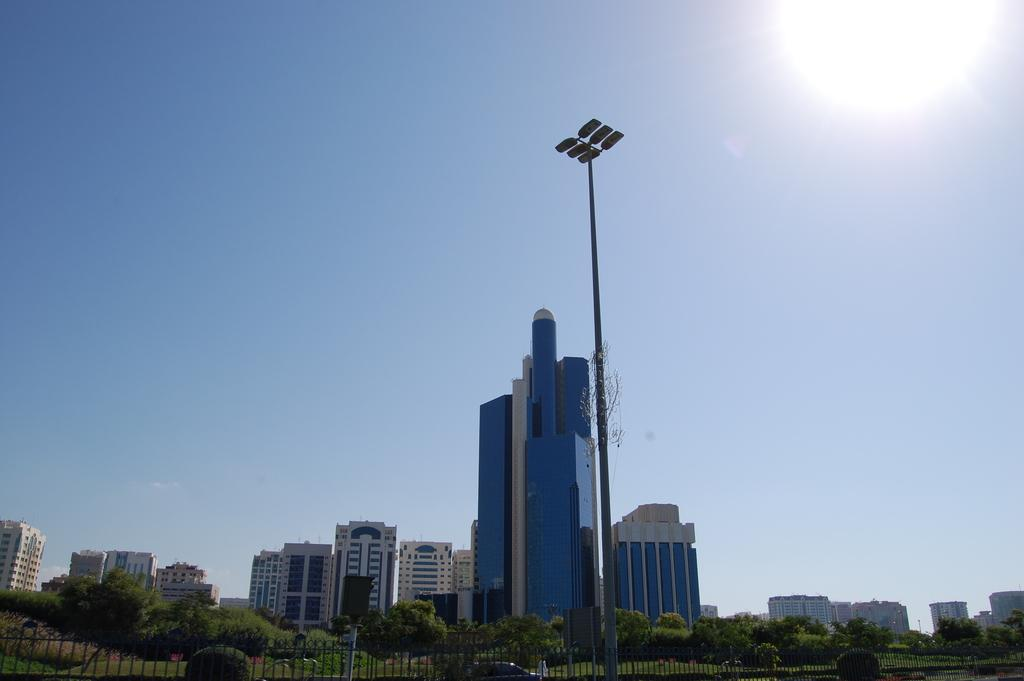What type of structures can be seen in the image? There are many buildings in the image. What natural elements are present in the image? Trees are present at the bottom of the image. What type of barrier can be seen in the image? There is a fencing in the image. What is located in the middle of the image? There is a pole in the middle of the image. What is visible at the top of the image? The sky is visible at the top of the image. How many rings are visible on the snake in the image? There is no snake present in the image, and therefore no rings can be observed. What time of day is depicted in the image, based on the hour? The provided facts do not mention the time of day or any hour, so it cannot be determined from the image. 